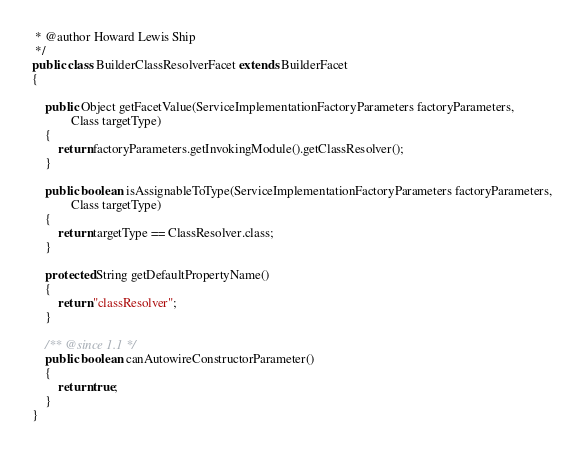Convert code to text. <code><loc_0><loc_0><loc_500><loc_500><_Java_> * @author Howard Lewis Ship
 */
public class BuilderClassResolverFacet extends BuilderFacet
{

    public Object getFacetValue(ServiceImplementationFactoryParameters factoryParameters,
            Class targetType)
    {
        return factoryParameters.getInvokingModule().getClassResolver();
    }

    public boolean isAssignableToType(ServiceImplementationFactoryParameters factoryParameters,
            Class targetType)
    {
        return targetType == ClassResolver.class;
    }

    protected String getDefaultPropertyName()
    {
        return "classResolver";
    }

    /** @since 1.1 */
    public boolean canAutowireConstructorParameter()
    {
        return true;
    }
}</code> 